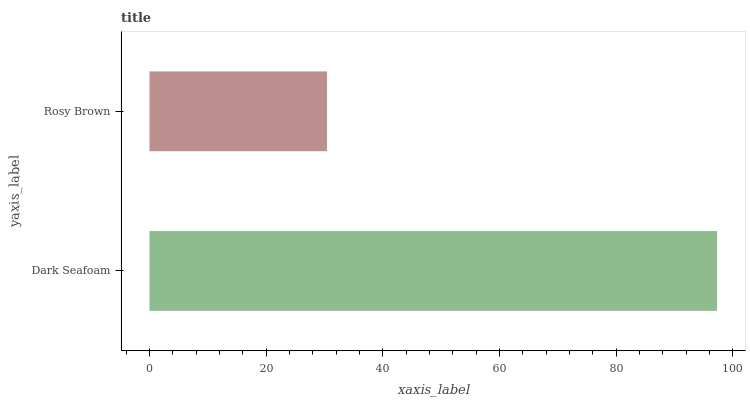Is Rosy Brown the minimum?
Answer yes or no. Yes. Is Dark Seafoam the maximum?
Answer yes or no. Yes. Is Rosy Brown the maximum?
Answer yes or no. No. Is Dark Seafoam greater than Rosy Brown?
Answer yes or no. Yes. Is Rosy Brown less than Dark Seafoam?
Answer yes or no. Yes. Is Rosy Brown greater than Dark Seafoam?
Answer yes or no. No. Is Dark Seafoam less than Rosy Brown?
Answer yes or no. No. Is Dark Seafoam the high median?
Answer yes or no. Yes. Is Rosy Brown the low median?
Answer yes or no. Yes. Is Rosy Brown the high median?
Answer yes or no. No. Is Dark Seafoam the low median?
Answer yes or no. No. 